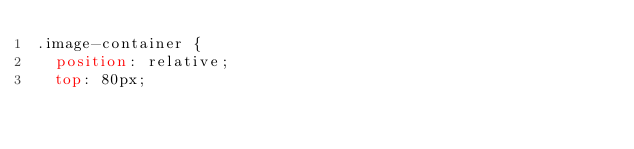Convert code to text. <code><loc_0><loc_0><loc_500><loc_500><_CSS_>.image-container {
  position: relative;
  top: 80px;</code> 